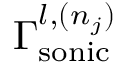Convert formula to latex. <formula><loc_0><loc_0><loc_500><loc_500>\Gamma _ { s o n i c } ^ { l , ( n _ { j } ) }</formula> 